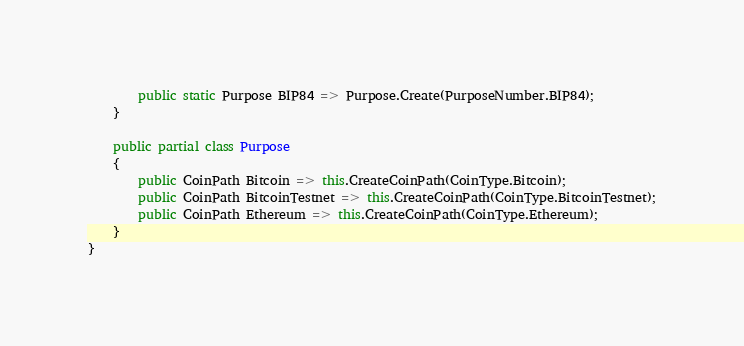Convert code to text. <code><loc_0><loc_0><loc_500><loc_500><_C#_>        public static Purpose BIP84 => Purpose.Create(PurposeNumber.BIP84);
    }

    public partial class Purpose
    {
        public CoinPath Bitcoin => this.CreateCoinPath(CoinType.Bitcoin);
        public CoinPath BitcoinTestnet => this.CreateCoinPath(CoinType.BitcoinTestnet);
        public CoinPath Ethereum => this.CreateCoinPath(CoinType.Ethereum);   
    }
}</code> 